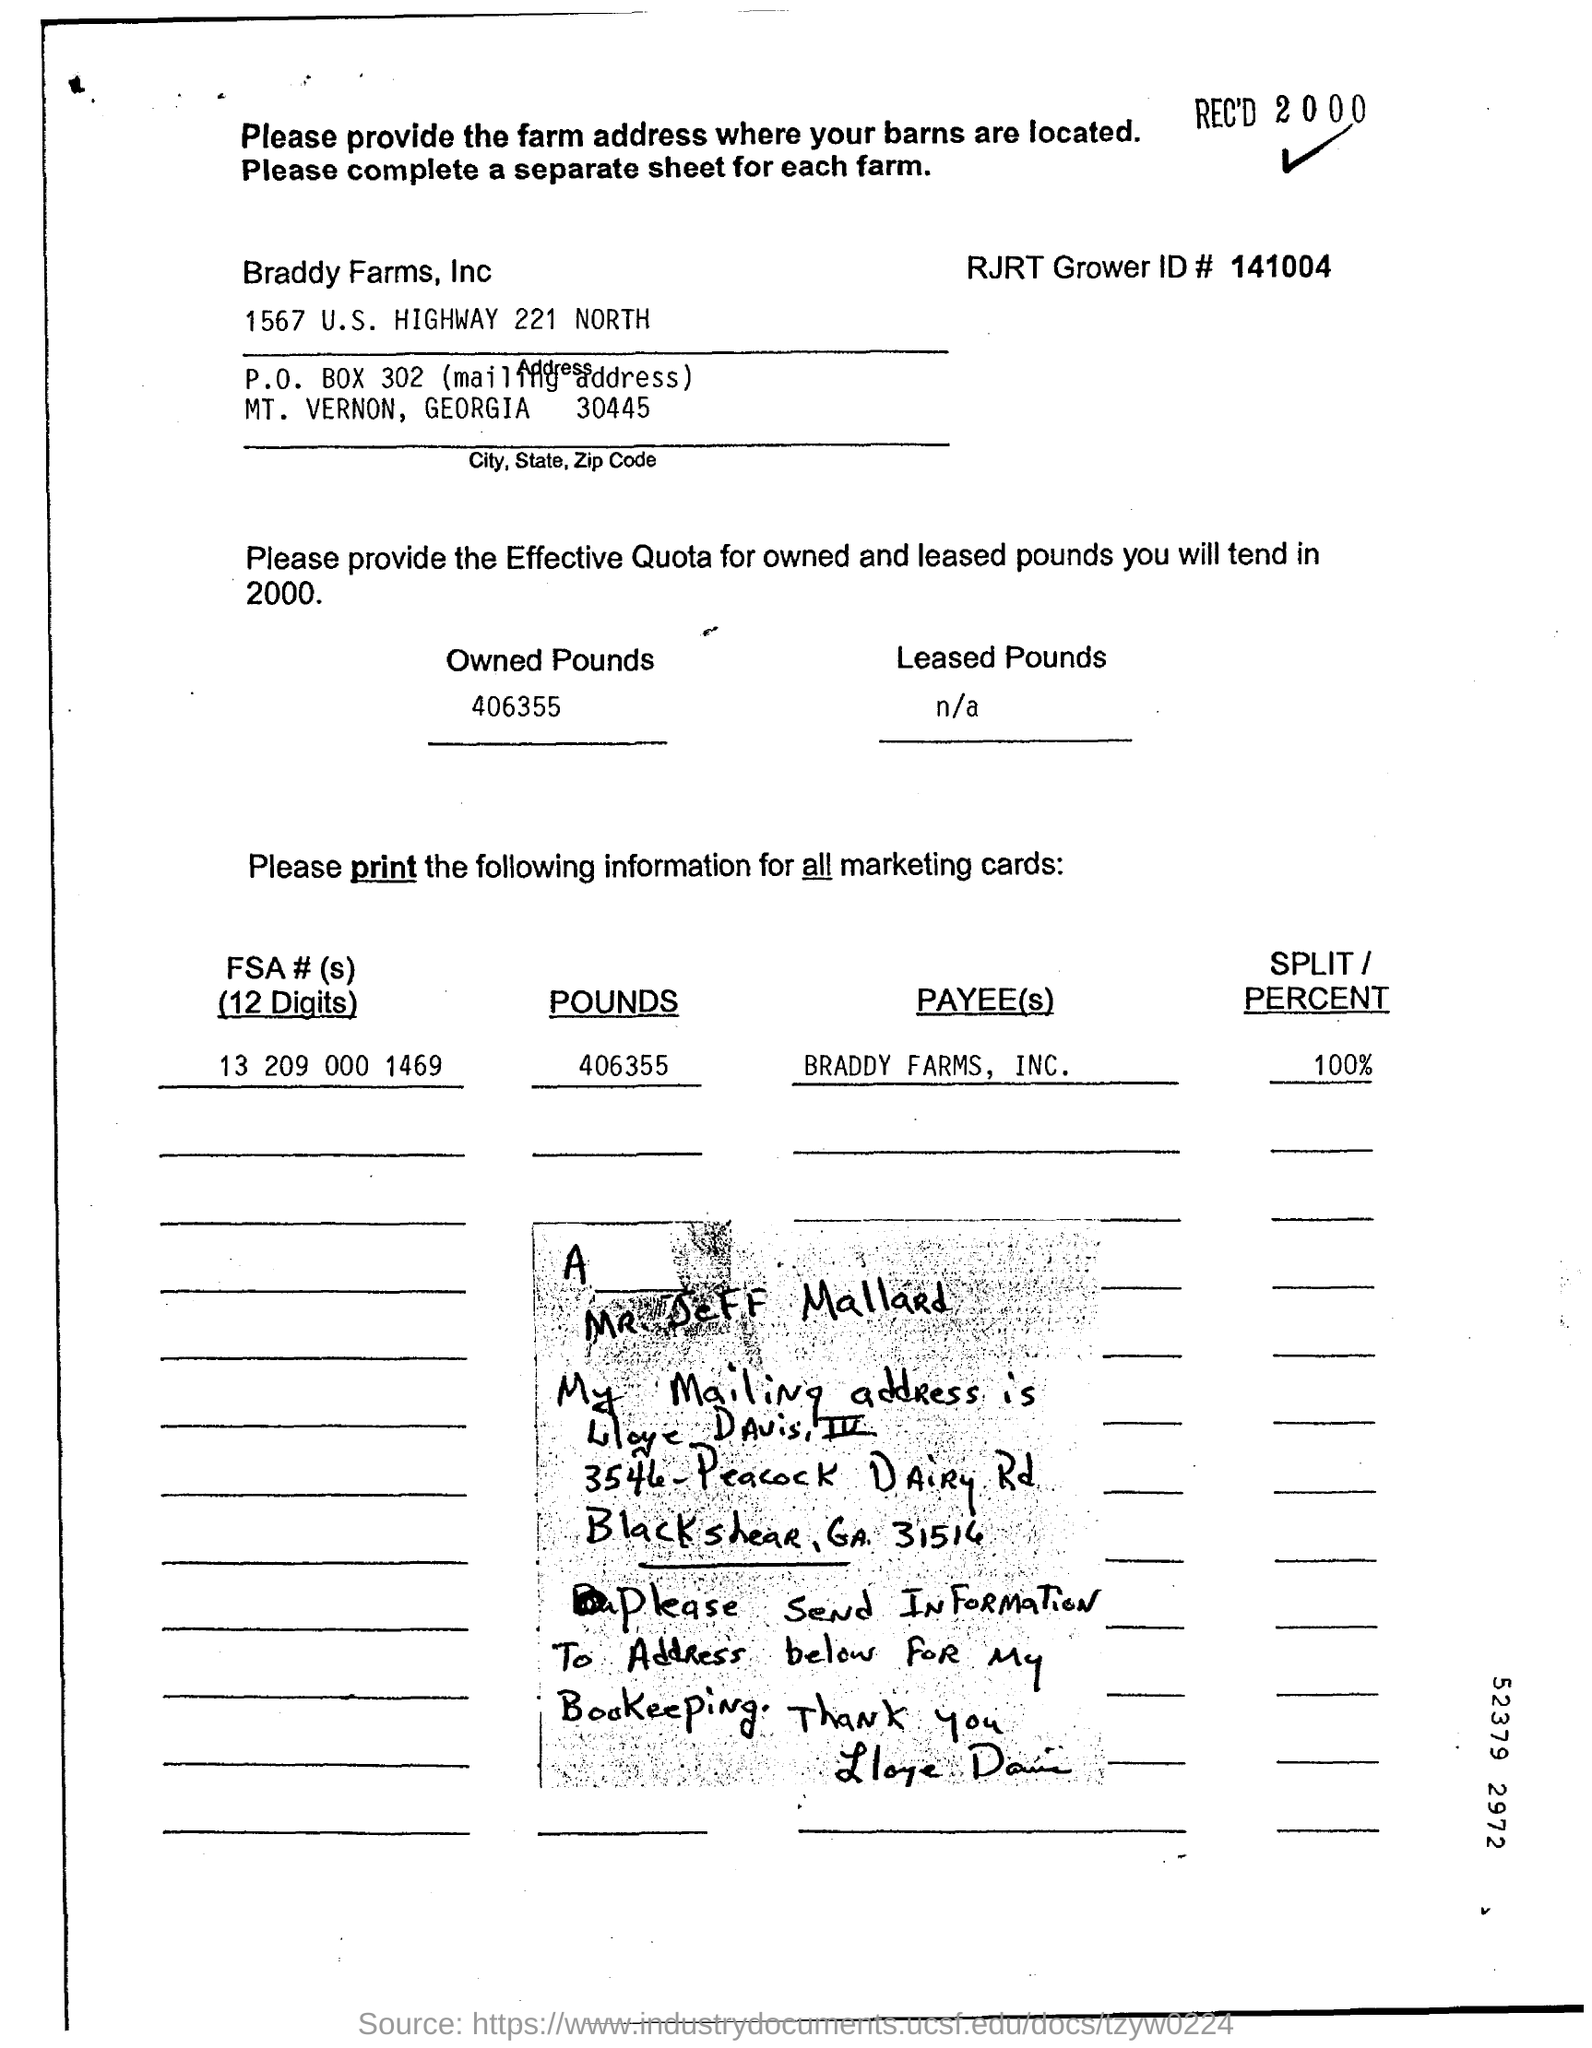What is RJRT Grower ID #?
Keep it short and to the point. 141004. What is FSA # (s)?
Provide a succinct answer. 13 209 000 1469. 